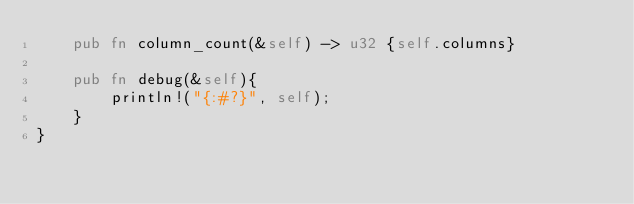Convert code to text. <code><loc_0><loc_0><loc_500><loc_500><_Rust_>    pub fn column_count(&self) -> u32 {self.columns}

    pub fn debug(&self){
        println!("{:#?}", self);
    }
}

</code> 